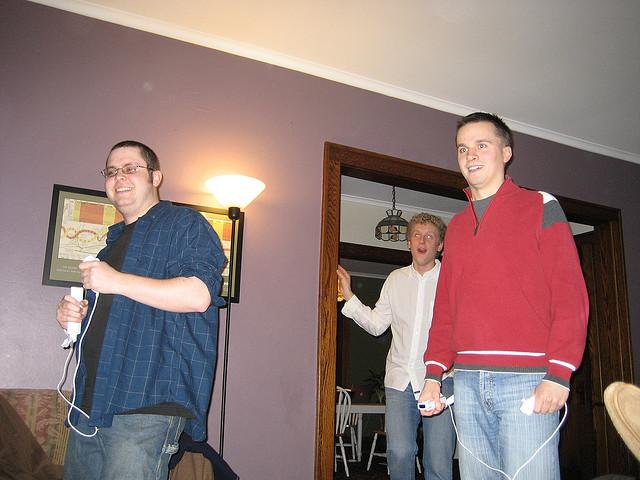What are they looking at? television 